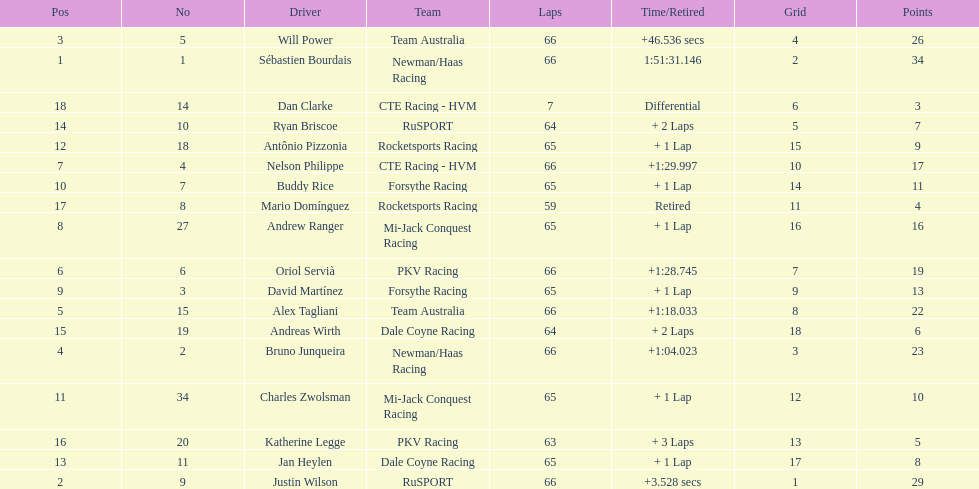At the 2006 gran premio telmex, who finished last? Dan Clarke. 